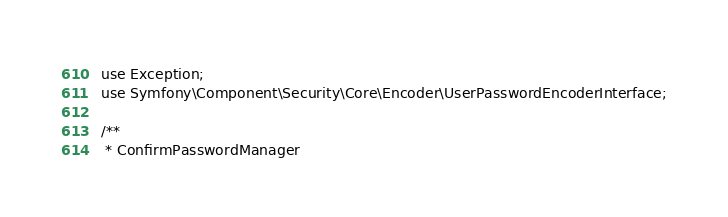Convert code to text. <code><loc_0><loc_0><loc_500><loc_500><_PHP_>use Exception;
use Symfony\Component\Security\Core\Encoder\UserPasswordEncoderInterface;

/**
 * ConfirmPasswordManager</code> 